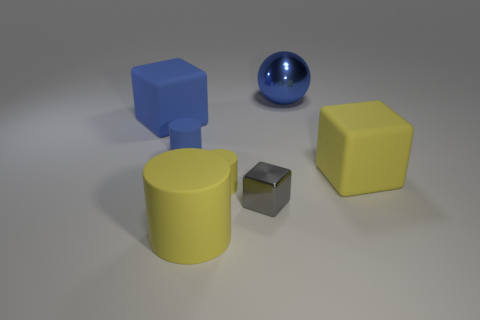Add 3 big blue metal balls. How many objects exist? 10 Subtract all spheres. How many objects are left? 6 Add 3 gray shiny cubes. How many gray shiny cubes are left? 4 Add 3 gray metal things. How many gray metal things exist? 4 Subtract 0 brown cubes. How many objects are left? 7 Subtract all large purple spheres. Subtract all yellow rubber cylinders. How many objects are left? 5 